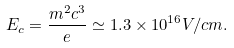<formula> <loc_0><loc_0><loc_500><loc_500>E _ { c } = \frac { m ^ { 2 } c ^ { 3 } } { e } \simeq 1 . 3 \times 1 0 ^ { 1 6 } V / c m .</formula> 